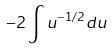Convert formula to latex. <formula><loc_0><loc_0><loc_500><loc_500>- 2 \int u ^ { - 1 / 2 } d u</formula> 